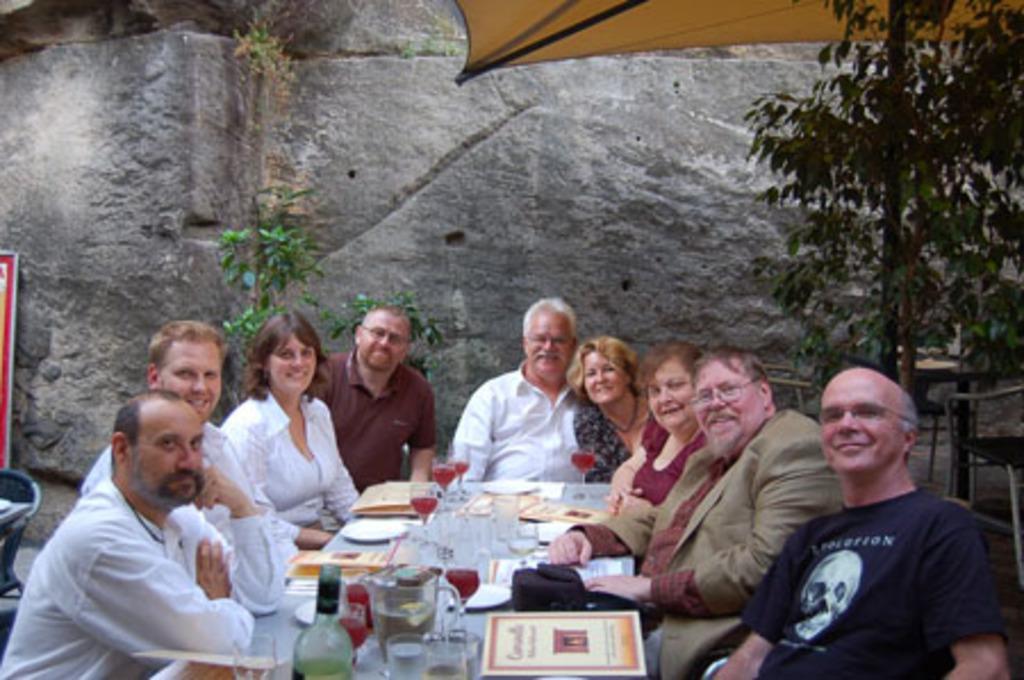Describe this image in one or two sentences. In this picture there are a group of people sitting and have a table in front of them with wine glasses and in the background is a rock and a plant 